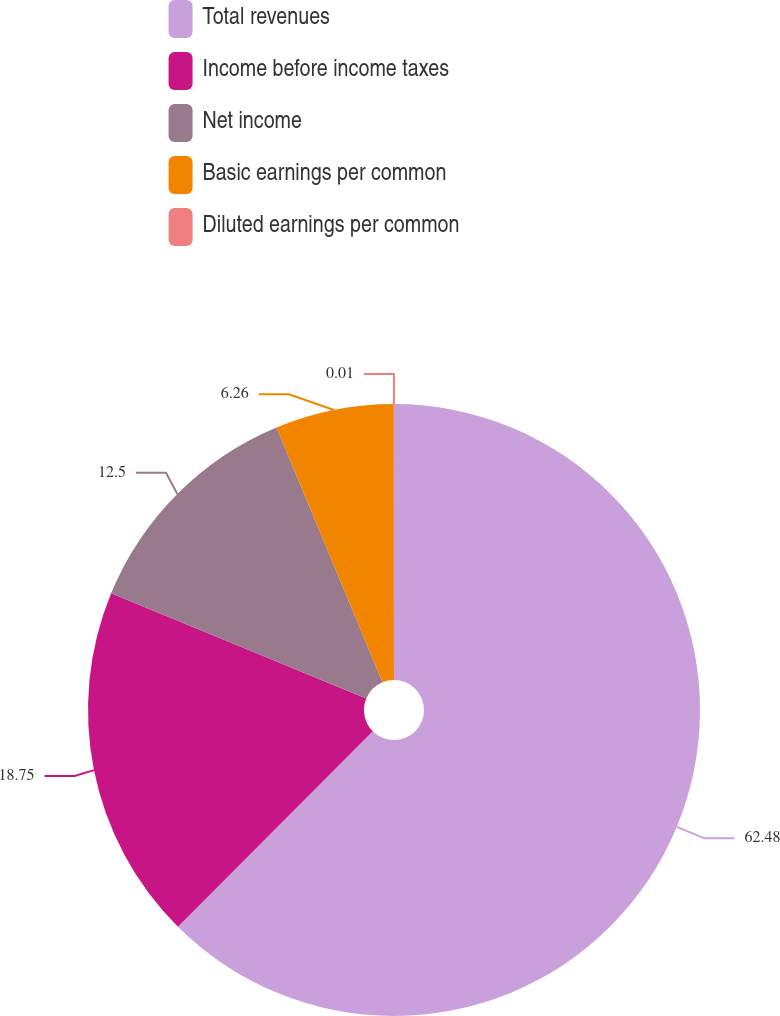<chart> <loc_0><loc_0><loc_500><loc_500><pie_chart><fcel>Total revenues<fcel>Income before income taxes<fcel>Net income<fcel>Basic earnings per common<fcel>Diluted earnings per common<nl><fcel>62.47%<fcel>18.75%<fcel>12.5%<fcel>6.26%<fcel>0.01%<nl></chart> 